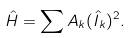Convert formula to latex. <formula><loc_0><loc_0><loc_500><loc_500>\hat { H } = \sum A _ { k } ( \hat { I } _ { k } ) ^ { 2 } .</formula> 